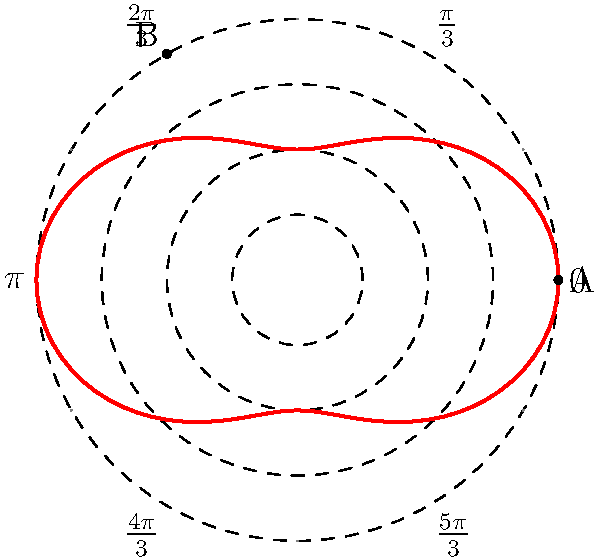In optimizing a robotic arm's movement path for an assembly line, you've modeled its reach using the polar equation $r = 3 + \cos(2\theta)$. If the arm needs to move from point A $(4,0)$ to point B $(-2,2\sqrt{3})$, what is the shortest angular distance (in radians) it should travel? Let's approach this step-by-step:

1) First, we need to find the angular coordinates of points A and B.

   For A $(4,0)$: 
   $\theta_A = 0$ (as it's on the positive x-axis)

   For B $(-2,2\sqrt{3})$:
   $\theta_B = \frac{2\pi}{3}$ (as it's 120° from the positive x-axis)

2) Now, we need to consider two possible paths:
   a) Moving counterclockwise from A to B
   b) Moving clockwise from A to B

3) The counterclockwise angular distance is simply:
   $\theta_B - \theta_A = \frac{2\pi}{3} - 0 = \frac{2\pi}{3}$

4) The clockwise angular distance is:
   $2\pi - (\theta_B - \theta_A) = 2\pi - \frac{2\pi}{3} = \frac{4\pi}{3}$

5) The shortest angular distance is the smaller of these two:
   $\min(\frac{2\pi}{3}, \frac{4\pi}{3}) = \frac{2\pi}{3}$

Therefore, the robotic arm should travel $\frac{2\pi}{3}$ radians counterclockwise for the most efficient path.
Answer: $\frac{2\pi}{3}$ radians 